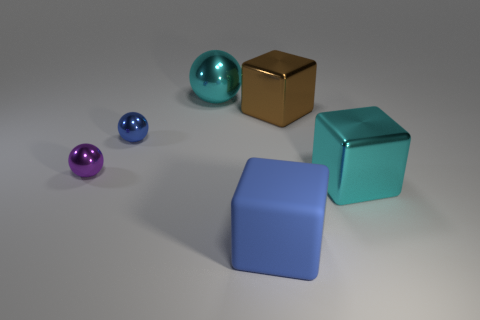Is the number of tiny shiny balls less than the number of large blue things?
Give a very brief answer. No. Does the large blue thing have the same material as the big cyan object that is in front of the brown shiny block?
Your answer should be compact. No. There is a tiny metallic object that is left of the tiny blue object; what is its shape?
Ensure brevity in your answer.  Sphere. Is there anything else that has the same color as the large sphere?
Your answer should be compact. Yes. Is the number of rubber objects that are right of the blue metal thing less than the number of tiny blue metallic balls?
Offer a very short reply. No. What number of objects have the same size as the blue block?
Offer a terse response. 3. There is a thing that is the same color as the rubber block; what shape is it?
Your answer should be compact. Sphere. What shape is the small purple metallic object that is to the left of the cyan object that is to the left of the cyan metallic object in front of the cyan metal sphere?
Provide a succinct answer. Sphere. What is the color of the large object left of the blue cube?
Give a very brief answer. Cyan. What number of objects are either big metallic things that are in front of the tiny blue ball or big objects on the right side of the blue rubber object?
Make the answer very short. 2. 